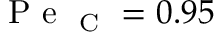Convert formula to latex. <formula><loc_0><loc_0><loc_500><loc_500>P e _ { C } = 0 . 9 5</formula> 